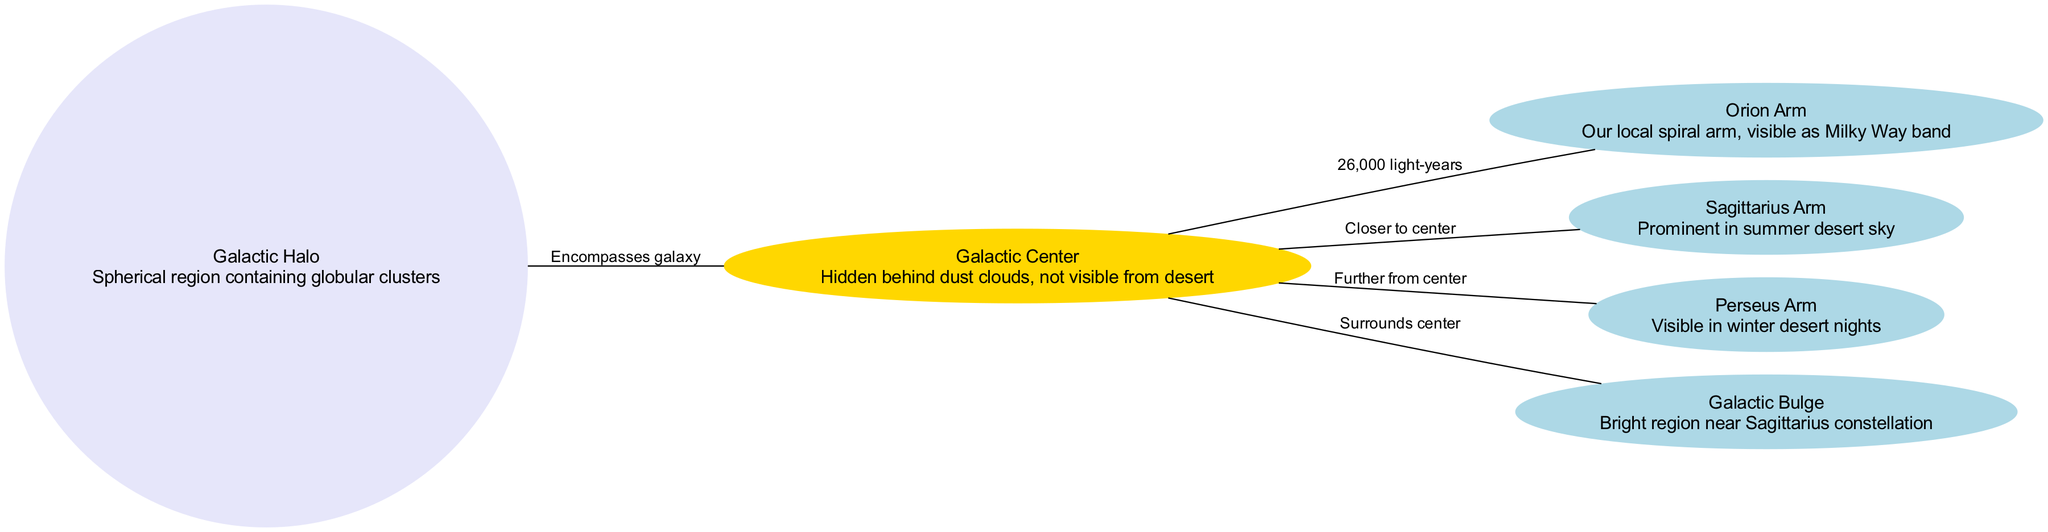What is the label of the node closest to the center of the Milky Way? The diagram indicates that the node closest to the center is labeled "Sagittarius Arm."
Answer: Sagittarius Arm How many nodes are present in the diagram? By counting the distinct nodes listed, we find there are six nodes in total: Galactic Center, Orion Arm, Sagittarius Arm, Perseus Arm, Galactic Bulge, and Galactic Halo.
Answer: 6 What does the Galactic Bulge surround? The diagram specifies that the Galactic Bulge surrounds the Galactic Center, as indicated by the relationship in the edges.
Answer: Galactic Center Which arm is described as our local spiral arm? The diagram designates "Orion Arm" as our local spiral arm.
Answer: Orion Arm Which region of the Milky Way is prominent in the summer desert sky? Referring to the diagram, it states that the "Sagittarius Arm" is prominent in the summer desert sky.
Answer: Sagittarius Arm What is the distance from the Galactic Center to the Orion Arm? According to the diagram, the distance is specified as 26,000 light-years.
Answer: 26,000 light-years Which component contains globular clusters? The diagram identifies the "Galactic Halo" as the component that contains globular clusters, as stated in its description.
Answer: Galactic Halo Which arm is visible in winter desert nights? The diagram mentions that the "Perseus Arm" is visible during winter desert nights.
Answer: Perseus Arm What color is the Galactic Center node represented in the diagram? The diagram indicates that the Galactic Center node is colored gold, as noted in the specific customizations for this node.
Answer: Gold 